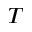<formula> <loc_0><loc_0><loc_500><loc_500>T</formula> 